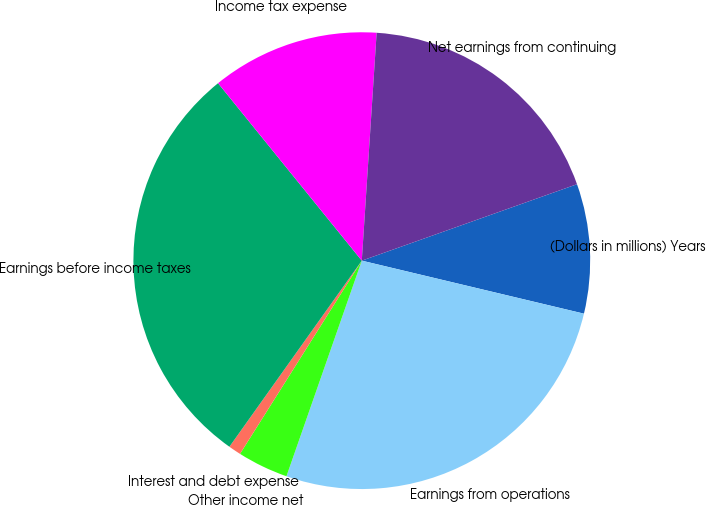Convert chart. <chart><loc_0><loc_0><loc_500><loc_500><pie_chart><fcel>(Dollars in millions) Years<fcel>Earnings from operations<fcel>Other income net<fcel>Interest and debt expense<fcel>Earnings before income taxes<fcel>Income tax expense<fcel>Net earnings from continuing<nl><fcel>9.16%<fcel>26.62%<fcel>3.6%<fcel>0.89%<fcel>29.32%<fcel>11.87%<fcel>18.53%<nl></chart> 